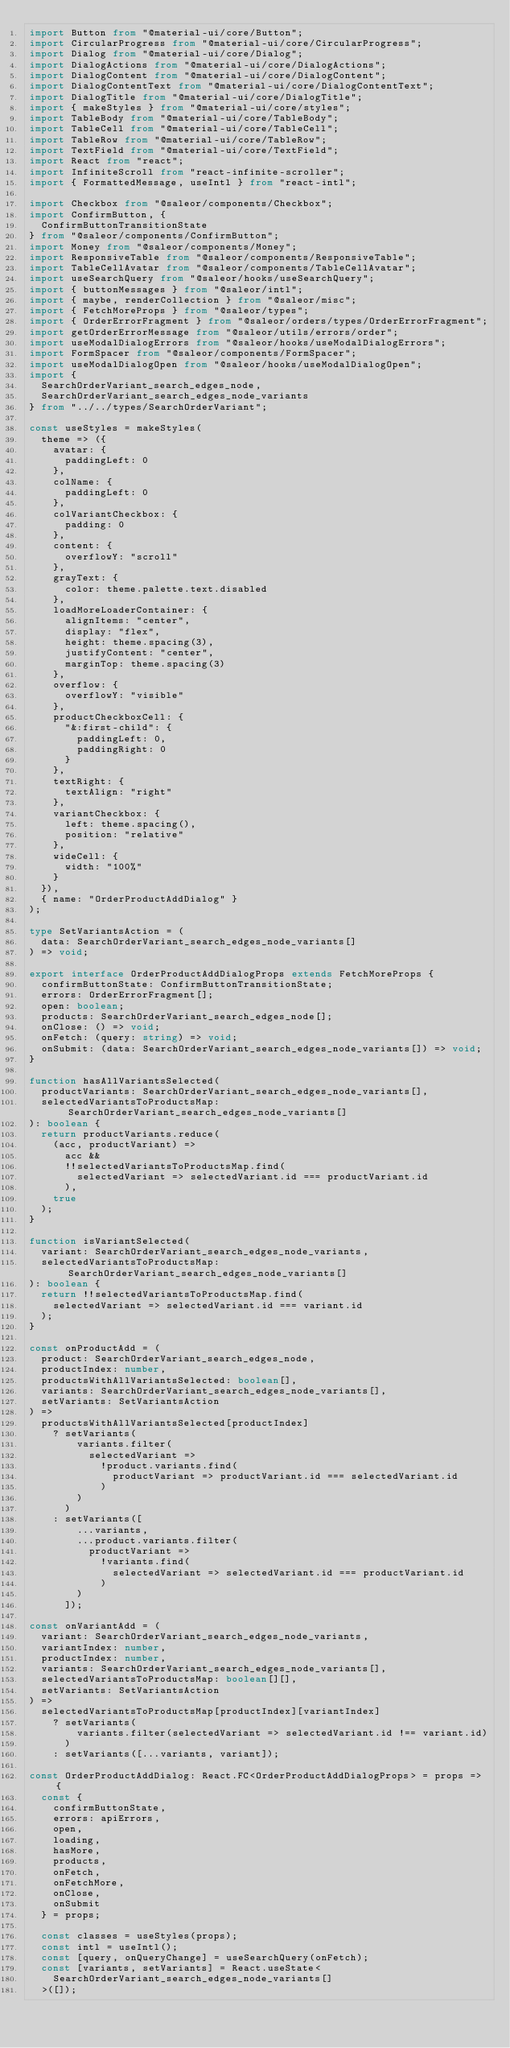<code> <loc_0><loc_0><loc_500><loc_500><_TypeScript_>import Button from "@material-ui/core/Button";
import CircularProgress from "@material-ui/core/CircularProgress";
import Dialog from "@material-ui/core/Dialog";
import DialogActions from "@material-ui/core/DialogActions";
import DialogContent from "@material-ui/core/DialogContent";
import DialogContentText from "@material-ui/core/DialogContentText";
import DialogTitle from "@material-ui/core/DialogTitle";
import { makeStyles } from "@material-ui/core/styles";
import TableBody from "@material-ui/core/TableBody";
import TableCell from "@material-ui/core/TableCell";
import TableRow from "@material-ui/core/TableRow";
import TextField from "@material-ui/core/TextField";
import React from "react";
import InfiniteScroll from "react-infinite-scroller";
import { FormattedMessage, useIntl } from "react-intl";

import Checkbox from "@saleor/components/Checkbox";
import ConfirmButton, {
  ConfirmButtonTransitionState
} from "@saleor/components/ConfirmButton";
import Money from "@saleor/components/Money";
import ResponsiveTable from "@saleor/components/ResponsiveTable";
import TableCellAvatar from "@saleor/components/TableCellAvatar";
import useSearchQuery from "@saleor/hooks/useSearchQuery";
import { buttonMessages } from "@saleor/intl";
import { maybe, renderCollection } from "@saleor/misc";
import { FetchMoreProps } from "@saleor/types";
import { OrderErrorFragment } from "@saleor/orders/types/OrderErrorFragment";
import getOrderErrorMessage from "@saleor/utils/errors/order";
import useModalDialogErrors from "@saleor/hooks/useModalDialogErrors";
import FormSpacer from "@saleor/components/FormSpacer";
import useModalDialogOpen from "@saleor/hooks/useModalDialogOpen";
import {
  SearchOrderVariant_search_edges_node,
  SearchOrderVariant_search_edges_node_variants
} from "../../types/SearchOrderVariant";

const useStyles = makeStyles(
  theme => ({
    avatar: {
      paddingLeft: 0
    },
    colName: {
      paddingLeft: 0
    },
    colVariantCheckbox: {
      padding: 0
    },
    content: {
      overflowY: "scroll"
    },
    grayText: {
      color: theme.palette.text.disabled
    },
    loadMoreLoaderContainer: {
      alignItems: "center",
      display: "flex",
      height: theme.spacing(3),
      justifyContent: "center",
      marginTop: theme.spacing(3)
    },
    overflow: {
      overflowY: "visible"
    },
    productCheckboxCell: {
      "&:first-child": {
        paddingLeft: 0,
        paddingRight: 0
      }
    },
    textRight: {
      textAlign: "right"
    },
    variantCheckbox: {
      left: theme.spacing(),
      position: "relative"
    },
    wideCell: {
      width: "100%"
    }
  }),
  { name: "OrderProductAddDialog" }
);

type SetVariantsAction = (
  data: SearchOrderVariant_search_edges_node_variants[]
) => void;

export interface OrderProductAddDialogProps extends FetchMoreProps {
  confirmButtonState: ConfirmButtonTransitionState;
  errors: OrderErrorFragment[];
  open: boolean;
  products: SearchOrderVariant_search_edges_node[];
  onClose: () => void;
  onFetch: (query: string) => void;
  onSubmit: (data: SearchOrderVariant_search_edges_node_variants[]) => void;
}

function hasAllVariantsSelected(
  productVariants: SearchOrderVariant_search_edges_node_variants[],
  selectedVariantsToProductsMap: SearchOrderVariant_search_edges_node_variants[]
): boolean {
  return productVariants.reduce(
    (acc, productVariant) =>
      acc &&
      !!selectedVariantsToProductsMap.find(
        selectedVariant => selectedVariant.id === productVariant.id
      ),
    true
  );
}

function isVariantSelected(
  variant: SearchOrderVariant_search_edges_node_variants,
  selectedVariantsToProductsMap: SearchOrderVariant_search_edges_node_variants[]
): boolean {
  return !!selectedVariantsToProductsMap.find(
    selectedVariant => selectedVariant.id === variant.id
  );
}

const onProductAdd = (
  product: SearchOrderVariant_search_edges_node,
  productIndex: number,
  productsWithAllVariantsSelected: boolean[],
  variants: SearchOrderVariant_search_edges_node_variants[],
  setVariants: SetVariantsAction
) =>
  productsWithAllVariantsSelected[productIndex]
    ? setVariants(
        variants.filter(
          selectedVariant =>
            !product.variants.find(
              productVariant => productVariant.id === selectedVariant.id
            )
        )
      )
    : setVariants([
        ...variants,
        ...product.variants.filter(
          productVariant =>
            !variants.find(
              selectedVariant => selectedVariant.id === productVariant.id
            )
        )
      ]);

const onVariantAdd = (
  variant: SearchOrderVariant_search_edges_node_variants,
  variantIndex: number,
  productIndex: number,
  variants: SearchOrderVariant_search_edges_node_variants[],
  selectedVariantsToProductsMap: boolean[][],
  setVariants: SetVariantsAction
) =>
  selectedVariantsToProductsMap[productIndex][variantIndex]
    ? setVariants(
        variants.filter(selectedVariant => selectedVariant.id !== variant.id)
      )
    : setVariants([...variants, variant]);

const OrderProductAddDialog: React.FC<OrderProductAddDialogProps> = props => {
  const {
    confirmButtonState,
    errors: apiErrors,
    open,
    loading,
    hasMore,
    products,
    onFetch,
    onFetchMore,
    onClose,
    onSubmit
  } = props;

  const classes = useStyles(props);
  const intl = useIntl();
  const [query, onQueryChange] = useSearchQuery(onFetch);
  const [variants, setVariants] = React.useState<
    SearchOrderVariant_search_edges_node_variants[]
  >([]);</code> 